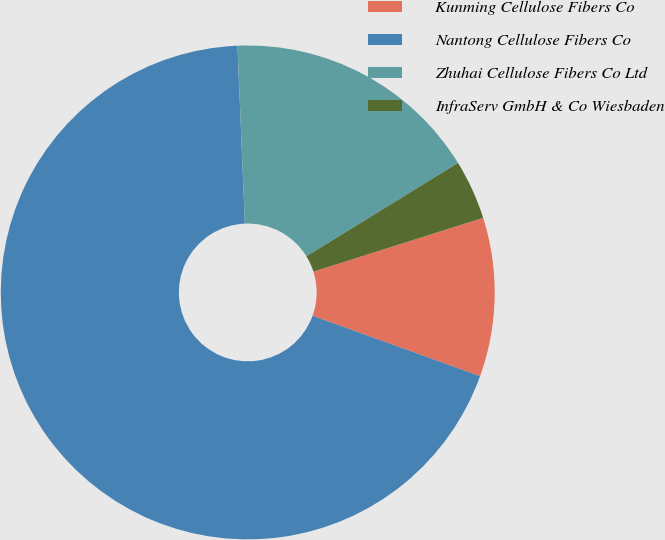<chart> <loc_0><loc_0><loc_500><loc_500><pie_chart><fcel>Kunming Cellulose Fibers Co<fcel>Nantong Cellulose Fibers Co<fcel>Zhuhai Cellulose Fibers Co Ltd<fcel>InfraServ GmbH & Co Wiesbaden<nl><fcel>10.39%<fcel>68.83%<fcel>16.88%<fcel>3.9%<nl></chart> 